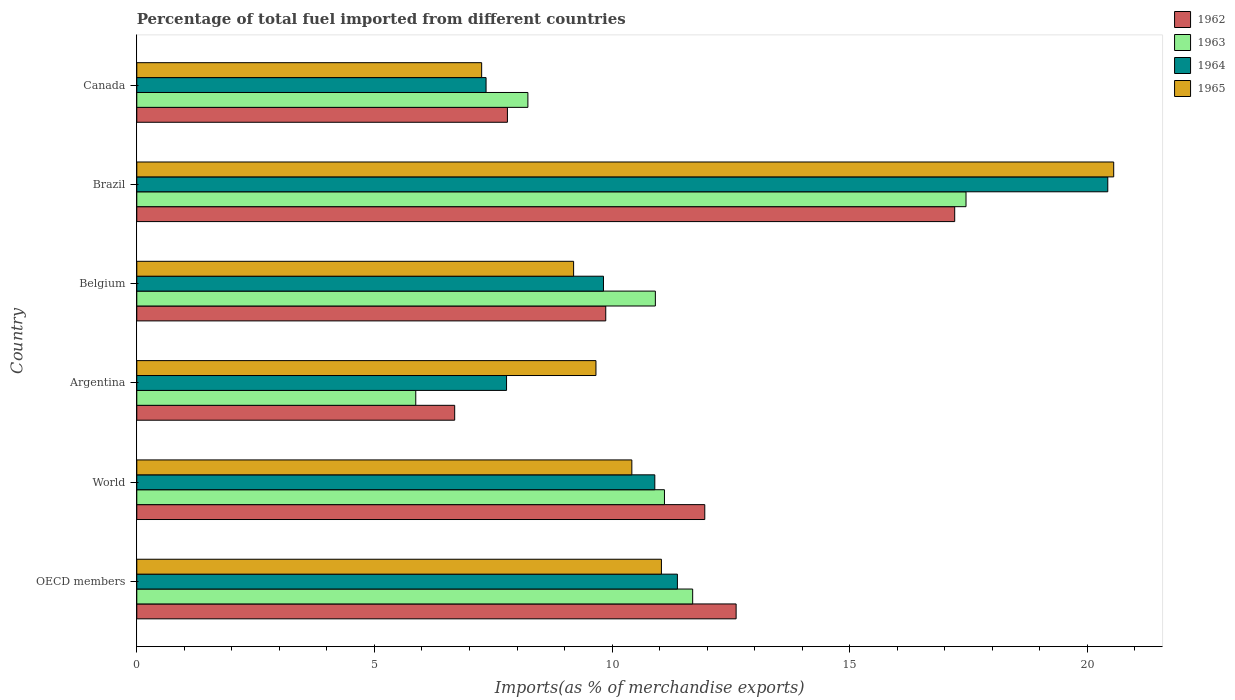How many different coloured bars are there?
Your answer should be very brief. 4. Are the number of bars per tick equal to the number of legend labels?
Provide a succinct answer. Yes. Are the number of bars on each tick of the Y-axis equal?
Provide a short and direct response. Yes. How many bars are there on the 3rd tick from the bottom?
Keep it short and to the point. 4. What is the percentage of imports to different countries in 1965 in Argentina?
Your answer should be compact. 9.66. Across all countries, what is the maximum percentage of imports to different countries in 1962?
Keep it short and to the point. 17.21. Across all countries, what is the minimum percentage of imports to different countries in 1963?
Keep it short and to the point. 5.87. In which country was the percentage of imports to different countries in 1963 minimum?
Give a very brief answer. Argentina. What is the total percentage of imports to different countries in 1965 in the graph?
Provide a succinct answer. 68.12. What is the difference between the percentage of imports to different countries in 1962 in Canada and that in OECD members?
Provide a succinct answer. -4.81. What is the difference between the percentage of imports to different countries in 1964 in OECD members and the percentage of imports to different countries in 1962 in Argentina?
Give a very brief answer. 4.69. What is the average percentage of imports to different countries in 1965 per country?
Provide a succinct answer. 11.35. What is the difference between the percentage of imports to different countries in 1963 and percentage of imports to different countries in 1962 in Belgium?
Provide a short and direct response. 1.04. In how many countries, is the percentage of imports to different countries in 1965 greater than 14 %?
Make the answer very short. 1. What is the ratio of the percentage of imports to different countries in 1963 in Belgium to that in OECD members?
Provide a succinct answer. 0.93. Is the percentage of imports to different countries in 1964 in Canada less than that in OECD members?
Ensure brevity in your answer.  Yes. What is the difference between the highest and the second highest percentage of imports to different countries in 1965?
Provide a short and direct response. 9.52. What is the difference between the highest and the lowest percentage of imports to different countries in 1965?
Keep it short and to the point. 13.3. In how many countries, is the percentage of imports to different countries in 1963 greater than the average percentage of imports to different countries in 1963 taken over all countries?
Provide a short and direct response. 4. What does the 2nd bar from the top in Belgium represents?
Make the answer very short. 1964. What does the 3rd bar from the bottom in Brazil represents?
Provide a succinct answer. 1964. Is it the case that in every country, the sum of the percentage of imports to different countries in 1965 and percentage of imports to different countries in 1962 is greater than the percentage of imports to different countries in 1963?
Your response must be concise. Yes. How many bars are there?
Provide a short and direct response. 24. Are all the bars in the graph horizontal?
Offer a very short reply. Yes. What is the difference between two consecutive major ticks on the X-axis?
Your answer should be compact. 5. Are the values on the major ticks of X-axis written in scientific E-notation?
Give a very brief answer. No. Does the graph contain any zero values?
Offer a terse response. No. How are the legend labels stacked?
Offer a terse response. Vertical. What is the title of the graph?
Make the answer very short. Percentage of total fuel imported from different countries. What is the label or title of the X-axis?
Your answer should be compact. Imports(as % of merchandise exports). What is the label or title of the Y-axis?
Provide a succinct answer. Country. What is the Imports(as % of merchandise exports) of 1962 in OECD members?
Your answer should be very brief. 12.61. What is the Imports(as % of merchandise exports) in 1963 in OECD members?
Your answer should be very brief. 11.7. What is the Imports(as % of merchandise exports) of 1964 in OECD members?
Offer a very short reply. 11.37. What is the Imports(as % of merchandise exports) of 1965 in OECD members?
Offer a very short reply. 11.04. What is the Imports(as % of merchandise exports) in 1962 in World?
Your answer should be very brief. 11.95. What is the Imports(as % of merchandise exports) in 1963 in World?
Make the answer very short. 11.1. What is the Imports(as % of merchandise exports) of 1964 in World?
Your answer should be compact. 10.9. What is the Imports(as % of merchandise exports) in 1965 in World?
Make the answer very short. 10.42. What is the Imports(as % of merchandise exports) of 1962 in Argentina?
Offer a terse response. 6.69. What is the Imports(as % of merchandise exports) in 1963 in Argentina?
Make the answer very short. 5.87. What is the Imports(as % of merchandise exports) of 1964 in Argentina?
Provide a succinct answer. 7.78. What is the Imports(as % of merchandise exports) of 1965 in Argentina?
Provide a short and direct response. 9.66. What is the Imports(as % of merchandise exports) in 1962 in Belgium?
Ensure brevity in your answer.  9.87. What is the Imports(as % of merchandise exports) in 1963 in Belgium?
Give a very brief answer. 10.91. What is the Imports(as % of merchandise exports) in 1964 in Belgium?
Offer a very short reply. 9.82. What is the Imports(as % of merchandise exports) in 1965 in Belgium?
Make the answer very short. 9.19. What is the Imports(as % of merchandise exports) of 1962 in Brazil?
Make the answer very short. 17.21. What is the Imports(as % of merchandise exports) in 1963 in Brazil?
Your answer should be compact. 17.45. What is the Imports(as % of merchandise exports) of 1964 in Brazil?
Ensure brevity in your answer.  20.43. What is the Imports(as % of merchandise exports) in 1965 in Brazil?
Your answer should be very brief. 20.55. What is the Imports(as % of merchandise exports) in 1962 in Canada?
Provide a short and direct response. 7.8. What is the Imports(as % of merchandise exports) of 1963 in Canada?
Your answer should be very brief. 8.23. What is the Imports(as % of merchandise exports) of 1964 in Canada?
Your answer should be compact. 7.35. What is the Imports(as % of merchandise exports) in 1965 in Canada?
Ensure brevity in your answer.  7.26. Across all countries, what is the maximum Imports(as % of merchandise exports) of 1962?
Provide a succinct answer. 17.21. Across all countries, what is the maximum Imports(as % of merchandise exports) of 1963?
Provide a short and direct response. 17.45. Across all countries, what is the maximum Imports(as % of merchandise exports) of 1964?
Your response must be concise. 20.43. Across all countries, what is the maximum Imports(as % of merchandise exports) in 1965?
Keep it short and to the point. 20.55. Across all countries, what is the minimum Imports(as % of merchandise exports) in 1962?
Make the answer very short. 6.69. Across all countries, what is the minimum Imports(as % of merchandise exports) in 1963?
Give a very brief answer. 5.87. Across all countries, what is the minimum Imports(as % of merchandise exports) of 1964?
Offer a very short reply. 7.35. Across all countries, what is the minimum Imports(as % of merchandise exports) in 1965?
Give a very brief answer. 7.26. What is the total Imports(as % of merchandise exports) of 1962 in the graph?
Your response must be concise. 66.12. What is the total Imports(as % of merchandise exports) in 1963 in the graph?
Offer a very short reply. 65.25. What is the total Imports(as % of merchandise exports) of 1964 in the graph?
Provide a succinct answer. 67.65. What is the total Imports(as % of merchandise exports) in 1965 in the graph?
Your answer should be compact. 68.12. What is the difference between the Imports(as % of merchandise exports) in 1962 in OECD members and that in World?
Offer a very short reply. 0.66. What is the difference between the Imports(as % of merchandise exports) in 1963 in OECD members and that in World?
Provide a short and direct response. 0.59. What is the difference between the Imports(as % of merchandise exports) in 1964 in OECD members and that in World?
Give a very brief answer. 0.48. What is the difference between the Imports(as % of merchandise exports) of 1965 in OECD members and that in World?
Offer a very short reply. 0.62. What is the difference between the Imports(as % of merchandise exports) in 1962 in OECD members and that in Argentina?
Offer a terse response. 5.92. What is the difference between the Imports(as % of merchandise exports) in 1963 in OECD members and that in Argentina?
Ensure brevity in your answer.  5.83. What is the difference between the Imports(as % of merchandise exports) of 1964 in OECD members and that in Argentina?
Offer a terse response. 3.59. What is the difference between the Imports(as % of merchandise exports) of 1965 in OECD members and that in Argentina?
Offer a terse response. 1.38. What is the difference between the Imports(as % of merchandise exports) in 1962 in OECD members and that in Belgium?
Your response must be concise. 2.74. What is the difference between the Imports(as % of merchandise exports) in 1963 in OECD members and that in Belgium?
Keep it short and to the point. 0.79. What is the difference between the Imports(as % of merchandise exports) of 1964 in OECD members and that in Belgium?
Keep it short and to the point. 1.56. What is the difference between the Imports(as % of merchandise exports) in 1965 in OECD members and that in Belgium?
Provide a short and direct response. 1.85. What is the difference between the Imports(as % of merchandise exports) of 1962 in OECD members and that in Brazil?
Keep it short and to the point. -4.6. What is the difference between the Imports(as % of merchandise exports) of 1963 in OECD members and that in Brazil?
Provide a succinct answer. -5.75. What is the difference between the Imports(as % of merchandise exports) of 1964 in OECD members and that in Brazil?
Your answer should be very brief. -9.06. What is the difference between the Imports(as % of merchandise exports) in 1965 in OECD members and that in Brazil?
Ensure brevity in your answer.  -9.52. What is the difference between the Imports(as % of merchandise exports) in 1962 in OECD members and that in Canada?
Keep it short and to the point. 4.81. What is the difference between the Imports(as % of merchandise exports) in 1963 in OECD members and that in Canada?
Your answer should be very brief. 3.47. What is the difference between the Imports(as % of merchandise exports) in 1964 in OECD members and that in Canada?
Offer a very short reply. 4.03. What is the difference between the Imports(as % of merchandise exports) of 1965 in OECD members and that in Canada?
Offer a terse response. 3.78. What is the difference between the Imports(as % of merchandise exports) of 1962 in World and that in Argentina?
Provide a succinct answer. 5.26. What is the difference between the Imports(as % of merchandise exports) in 1963 in World and that in Argentina?
Your answer should be compact. 5.23. What is the difference between the Imports(as % of merchandise exports) in 1964 in World and that in Argentina?
Offer a very short reply. 3.12. What is the difference between the Imports(as % of merchandise exports) in 1965 in World and that in Argentina?
Your answer should be compact. 0.76. What is the difference between the Imports(as % of merchandise exports) in 1962 in World and that in Belgium?
Offer a terse response. 2.08. What is the difference between the Imports(as % of merchandise exports) in 1963 in World and that in Belgium?
Keep it short and to the point. 0.19. What is the difference between the Imports(as % of merchandise exports) of 1964 in World and that in Belgium?
Provide a succinct answer. 1.08. What is the difference between the Imports(as % of merchandise exports) in 1965 in World and that in Belgium?
Ensure brevity in your answer.  1.23. What is the difference between the Imports(as % of merchandise exports) in 1962 in World and that in Brazil?
Your answer should be compact. -5.26. What is the difference between the Imports(as % of merchandise exports) of 1963 in World and that in Brazil?
Your answer should be compact. -6.34. What is the difference between the Imports(as % of merchandise exports) in 1964 in World and that in Brazil?
Your answer should be compact. -9.53. What is the difference between the Imports(as % of merchandise exports) of 1965 in World and that in Brazil?
Provide a succinct answer. -10.14. What is the difference between the Imports(as % of merchandise exports) in 1962 in World and that in Canada?
Keep it short and to the point. 4.15. What is the difference between the Imports(as % of merchandise exports) in 1963 in World and that in Canada?
Give a very brief answer. 2.87. What is the difference between the Imports(as % of merchandise exports) of 1964 in World and that in Canada?
Ensure brevity in your answer.  3.55. What is the difference between the Imports(as % of merchandise exports) of 1965 in World and that in Canada?
Your response must be concise. 3.16. What is the difference between the Imports(as % of merchandise exports) in 1962 in Argentina and that in Belgium?
Ensure brevity in your answer.  -3.18. What is the difference between the Imports(as % of merchandise exports) of 1963 in Argentina and that in Belgium?
Offer a terse response. -5.04. What is the difference between the Imports(as % of merchandise exports) in 1964 in Argentina and that in Belgium?
Your response must be concise. -2.04. What is the difference between the Imports(as % of merchandise exports) of 1965 in Argentina and that in Belgium?
Make the answer very short. 0.47. What is the difference between the Imports(as % of merchandise exports) in 1962 in Argentina and that in Brazil?
Offer a terse response. -10.52. What is the difference between the Imports(as % of merchandise exports) of 1963 in Argentina and that in Brazil?
Offer a very short reply. -11.58. What is the difference between the Imports(as % of merchandise exports) of 1964 in Argentina and that in Brazil?
Your answer should be very brief. -12.65. What is the difference between the Imports(as % of merchandise exports) of 1965 in Argentina and that in Brazil?
Offer a very short reply. -10.89. What is the difference between the Imports(as % of merchandise exports) in 1962 in Argentina and that in Canada?
Provide a succinct answer. -1.11. What is the difference between the Imports(as % of merchandise exports) in 1963 in Argentina and that in Canada?
Ensure brevity in your answer.  -2.36. What is the difference between the Imports(as % of merchandise exports) in 1964 in Argentina and that in Canada?
Keep it short and to the point. 0.43. What is the difference between the Imports(as % of merchandise exports) in 1965 in Argentina and that in Canada?
Provide a short and direct response. 2.4. What is the difference between the Imports(as % of merchandise exports) of 1962 in Belgium and that in Brazil?
Your answer should be very brief. -7.34. What is the difference between the Imports(as % of merchandise exports) of 1963 in Belgium and that in Brazil?
Offer a very short reply. -6.54. What is the difference between the Imports(as % of merchandise exports) of 1964 in Belgium and that in Brazil?
Offer a terse response. -10.61. What is the difference between the Imports(as % of merchandise exports) of 1965 in Belgium and that in Brazil?
Ensure brevity in your answer.  -11.36. What is the difference between the Imports(as % of merchandise exports) in 1962 in Belgium and that in Canada?
Give a very brief answer. 2.07. What is the difference between the Imports(as % of merchandise exports) of 1963 in Belgium and that in Canada?
Your answer should be very brief. 2.68. What is the difference between the Imports(as % of merchandise exports) in 1964 in Belgium and that in Canada?
Offer a very short reply. 2.47. What is the difference between the Imports(as % of merchandise exports) of 1965 in Belgium and that in Canada?
Offer a very short reply. 1.93. What is the difference between the Imports(as % of merchandise exports) in 1962 in Brazil and that in Canada?
Provide a succinct answer. 9.41. What is the difference between the Imports(as % of merchandise exports) of 1963 in Brazil and that in Canada?
Provide a short and direct response. 9.22. What is the difference between the Imports(as % of merchandise exports) of 1964 in Brazil and that in Canada?
Offer a very short reply. 13.08. What is the difference between the Imports(as % of merchandise exports) of 1965 in Brazil and that in Canada?
Give a very brief answer. 13.3. What is the difference between the Imports(as % of merchandise exports) in 1962 in OECD members and the Imports(as % of merchandise exports) in 1963 in World?
Give a very brief answer. 1.51. What is the difference between the Imports(as % of merchandise exports) in 1962 in OECD members and the Imports(as % of merchandise exports) in 1964 in World?
Ensure brevity in your answer.  1.71. What is the difference between the Imports(as % of merchandise exports) of 1962 in OECD members and the Imports(as % of merchandise exports) of 1965 in World?
Provide a succinct answer. 2.19. What is the difference between the Imports(as % of merchandise exports) in 1963 in OECD members and the Imports(as % of merchandise exports) in 1964 in World?
Provide a short and direct response. 0.8. What is the difference between the Imports(as % of merchandise exports) in 1963 in OECD members and the Imports(as % of merchandise exports) in 1965 in World?
Offer a terse response. 1.28. What is the difference between the Imports(as % of merchandise exports) in 1964 in OECD members and the Imports(as % of merchandise exports) in 1965 in World?
Ensure brevity in your answer.  0.96. What is the difference between the Imports(as % of merchandise exports) in 1962 in OECD members and the Imports(as % of merchandise exports) in 1963 in Argentina?
Provide a short and direct response. 6.74. What is the difference between the Imports(as % of merchandise exports) in 1962 in OECD members and the Imports(as % of merchandise exports) in 1964 in Argentina?
Offer a terse response. 4.83. What is the difference between the Imports(as % of merchandise exports) in 1962 in OECD members and the Imports(as % of merchandise exports) in 1965 in Argentina?
Provide a succinct answer. 2.95. What is the difference between the Imports(as % of merchandise exports) of 1963 in OECD members and the Imports(as % of merchandise exports) of 1964 in Argentina?
Give a very brief answer. 3.92. What is the difference between the Imports(as % of merchandise exports) in 1963 in OECD members and the Imports(as % of merchandise exports) in 1965 in Argentina?
Provide a short and direct response. 2.04. What is the difference between the Imports(as % of merchandise exports) in 1964 in OECD members and the Imports(as % of merchandise exports) in 1965 in Argentina?
Ensure brevity in your answer.  1.71. What is the difference between the Imports(as % of merchandise exports) in 1962 in OECD members and the Imports(as % of merchandise exports) in 1963 in Belgium?
Make the answer very short. 1.7. What is the difference between the Imports(as % of merchandise exports) in 1962 in OECD members and the Imports(as % of merchandise exports) in 1964 in Belgium?
Make the answer very short. 2.79. What is the difference between the Imports(as % of merchandise exports) of 1962 in OECD members and the Imports(as % of merchandise exports) of 1965 in Belgium?
Offer a terse response. 3.42. What is the difference between the Imports(as % of merchandise exports) in 1963 in OECD members and the Imports(as % of merchandise exports) in 1964 in Belgium?
Offer a very short reply. 1.88. What is the difference between the Imports(as % of merchandise exports) in 1963 in OECD members and the Imports(as % of merchandise exports) in 1965 in Belgium?
Offer a very short reply. 2.51. What is the difference between the Imports(as % of merchandise exports) of 1964 in OECD members and the Imports(as % of merchandise exports) of 1965 in Belgium?
Keep it short and to the point. 2.18. What is the difference between the Imports(as % of merchandise exports) of 1962 in OECD members and the Imports(as % of merchandise exports) of 1963 in Brazil?
Your response must be concise. -4.84. What is the difference between the Imports(as % of merchandise exports) in 1962 in OECD members and the Imports(as % of merchandise exports) in 1964 in Brazil?
Offer a very short reply. -7.82. What is the difference between the Imports(as % of merchandise exports) in 1962 in OECD members and the Imports(as % of merchandise exports) in 1965 in Brazil?
Your answer should be very brief. -7.94. What is the difference between the Imports(as % of merchandise exports) of 1963 in OECD members and the Imports(as % of merchandise exports) of 1964 in Brazil?
Your response must be concise. -8.73. What is the difference between the Imports(as % of merchandise exports) of 1963 in OECD members and the Imports(as % of merchandise exports) of 1965 in Brazil?
Your answer should be very brief. -8.86. What is the difference between the Imports(as % of merchandise exports) of 1964 in OECD members and the Imports(as % of merchandise exports) of 1965 in Brazil?
Keep it short and to the point. -9.18. What is the difference between the Imports(as % of merchandise exports) of 1962 in OECD members and the Imports(as % of merchandise exports) of 1963 in Canada?
Your answer should be very brief. 4.38. What is the difference between the Imports(as % of merchandise exports) in 1962 in OECD members and the Imports(as % of merchandise exports) in 1964 in Canada?
Your response must be concise. 5.26. What is the difference between the Imports(as % of merchandise exports) in 1962 in OECD members and the Imports(as % of merchandise exports) in 1965 in Canada?
Ensure brevity in your answer.  5.35. What is the difference between the Imports(as % of merchandise exports) in 1963 in OECD members and the Imports(as % of merchandise exports) in 1964 in Canada?
Make the answer very short. 4.35. What is the difference between the Imports(as % of merchandise exports) in 1963 in OECD members and the Imports(as % of merchandise exports) in 1965 in Canada?
Keep it short and to the point. 4.44. What is the difference between the Imports(as % of merchandise exports) of 1964 in OECD members and the Imports(as % of merchandise exports) of 1965 in Canada?
Your answer should be compact. 4.12. What is the difference between the Imports(as % of merchandise exports) of 1962 in World and the Imports(as % of merchandise exports) of 1963 in Argentina?
Offer a terse response. 6.08. What is the difference between the Imports(as % of merchandise exports) of 1962 in World and the Imports(as % of merchandise exports) of 1964 in Argentina?
Your answer should be compact. 4.17. What is the difference between the Imports(as % of merchandise exports) in 1962 in World and the Imports(as % of merchandise exports) in 1965 in Argentina?
Your answer should be compact. 2.29. What is the difference between the Imports(as % of merchandise exports) in 1963 in World and the Imports(as % of merchandise exports) in 1964 in Argentina?
Your answer should be compact. 3.32. What is the difference between the Imports(as % of merchandise exports) in 1963 in World and the Imports(as % of merchandise exports) in 1965 in Argentina?
Keep it short and to the point. 1.44. What is the difference between the Imports(as % of merchandise exports) of 1964 in World and the Imports(as % of merchandise exports) of 1965 in Argentina?
Offer a terse response. 1.24. What is the difference between the Imports(as % of merchandise exports) of 1962 in World and the Imports(as % of merchandise exports) of 1963 in Belgium?
Your response must be concise. 1.04. What is the difference between the Imports(as % of merchandise exports) of 1962 in World and the Imports(as % of merchandise exports) of 1964 in Belgium?
Offer a terse response. 2.13. What is the difference between the Imports(as % of merchandise exports) in 1962 in World and the Imports(as % of merchandise exports) in 1965 in Belgium?
Your response must be concise. 2.76. What is the difference between the Imports(as % of merchandise exports) of 1963 in World and the Imports(as % of merchandise exports) of 1964 in Belgium?
Give a very brief answer. 1.28. What is the difference between the Imports(as % of merchandise exports) in 1963 in World and the Imports(as % of merchandise exports) in 1965 in Belgium?
Give a very brief answer. 1.91. What is the difference between the Imports(as % of merchandise exports) in 1964 in World and the Imports(as % of merchandise exports) in 1965 in Belgium?
Give a very brief answer. 1.71. What is the difference between the Imports(as % of merchandise exports) in 1962 in World and the Imports(as % of merchandise exports) in 1963 in Brazil?
Your answer should be compact. -5.5. What is the difference between the Imports(as % of merchandise exports) in 1962 in World and the Imports(as % of merchandise exports) in 1964 in Brazil?
Offer a very short reply. -8.48. What is the difference between the Imports(as % of merchandise exports) of 1962 in World and the Imports(as % of merchandise exports) of 1965 in Brazil?
Keep it short and to the point. -8.6. What is the difference between the Imports(as % of merchandise exports) of 1963 in World and the Imports(as % of merchandise exports) of 1964 in Brazil?
Your response must be concise. -9.33. What is the difference between the Imports(as % of merchandise exports) in 1963 in World and the Imports(as % of merchandise exports) in 1965 in Brazil?
Offer a very short reply. -9.45. What is the difference between the Imports(as % of merchandise exports) of 1964 in World and the Imports(as % of merchandise exports) of 1965 in Brazil?
Ensure brevity in your answer.  -9.66. What is the difference between the Imports(as % of merchandise exports) of 1962 in World and the Imports(as % of merchandise exports) of 1963 in Canada?
Provide a short and direct response. 3.72. What is the difference between the Imports(as % of merchandise exports) of 1962 in World and the Imports(as % of merchandise exports) of 1964 in Canada?
Offer a terse response. 4.6. What is the difference between the Imports(as % of merchandise exports) in 1962 in World and the Imports(as % of merchandise exports) in 1965 in Canada?
Give a very brief answer. 4.69. What is the difference between the Imports(as % of merchandise exports) in 1963 in World and the Imports(as % of merchandise exports) in 1964 in Canada?
Keep it short and to the point. 3.75. What is the difference between the Imports(as % of merchandise exports) in 1963 in World and the Imports(as % of merchandise exports) in 1965 in Canada?
Your answer should be compact. 3.85. What is the difference between the Imports(as % of merchandise exports) in 1964 in World and the Imports(as % of merchandise exports) in 1965 in Canada?
Your response must be concise. 3.64. What is the difference between the Imports(as % of merchandise exports) of 1962 in Argentina and the Imports(as % of merchandise exports) of 1963 in Belgium?
Your response must be concise. -4.22. What is the difference between the Imports(as % of merchandise exports) of 1962 in Argentina and the Imports(as % of merchandise exports) of 1964 in Belgium?
Make the answer very short. -3.13. What is the difference between the Imports(as % of merchandise exports) of 1962 in Argentina and the Imports(as % of merchandise exports) of 1965 in Belgium?
Your response must be concise. -2.5. What is the difference between the Imports(as % of merchandise exports) of 1963 in Argentina and the Imports(as % of merchandise exports) of 1964 in Belgium?
Ensure brevity in your answer.  -3.95. What is the difference between the Imports(as % of merchandise exports) in 1963 in Argentina and the Imports(as % of merchandise exports) in 1965 in Belgium?
Your answer should be compact. -3.32. What is the difference between the Imports(as % of merchandise exports) of 1964 in Argentina and the Imports(as % of merchandise exports) of 1965 in Belgium?
Make the answer very short. -1.41. What is the difference between the Imports(as % of merchandise exports) in 1962 in Argentina and the Imports(as % of merchandise exports) in 1963 in Brazil?
Your answer should be very brief. -10.76. What is the difference between the Imports(as % of merchandise exports) in 1962 in Argentina and the Imports(as % of merchandise exports) in 1964 in Brazil?
Provide a succinct answer. -13.74. What is the difference between the Imports(as % of merchandise exports) of 1962 in Argentina and the Imports(as % of merchandise exports) of 1965 in Brazil?
Offer a terse response. -13.87. What is the difference between the Imports(as % of merchandise exports) in 1963 in Argentina and the Imports(as % of merchandise exports) in 1964 in Brazil?
Your answer should be compact. -14.56. What is the difference between the Imports(as % of merchandise exports) in 1963 in Argentina and the Imports(as % of merchandise exports) in 1965 in Brazil?
Your answer should be compact. -14.68. What is the difference between the Imports(as % of merchandise exports) of 1964 in Argentina and the Imports(as % of merchandise exports) of 1965 in Brazil?
Offer a terse response. -12.77. What is the difference between the Imports(as % of merchandise exports) of 1962 in Argentina and the Imports(as % of merchandise exports) of 1963 in Canada?
Your answer should be compact. -1.54. What is the difference between the Imports(as % of merchandise exports) in 1962 in Argentina and the Imports(as % of merchandise exports) in 1964 in Canada?
Keep it short and to the point. -0.66. What is the difference between the Imports(as % of merchandise exports) of 1962 in Argentina and the Imports(as % of merchandise exports) of 1965 in Canada?
Keep it short and to the point. -0.57. What is the difference between the Imports(as % of merchandise exports) in 1963 in Argentina and the Imports(as % of merchandise exports) in 1964 in Canada?
Offer a terse response. -1.48. What is the difference between the Imports(as % of merchandise exports) of 1963 in Argentina and the Imports(as % of merchandise exports) of 1965 in Canada?
Provide a short and direct response. -1.39. What is the difference between the Imports(as % of merchandise exports) of 1964 in Argentina and the Imports(as % of merchandise exports) of 1965 in Canada?
Provide a succinct answer. 0.52. What is the difference between the Imports(as % of merchandise exports) in 1962 in Belgium and the Imports(as % of merchandise exports) in 1963 in Brazil?
Your answer should be very brief. -7.58. What is the difference between the Imports(as % of merchandise exports) in 1962 in Belgium and the Imports(as % of merchandise exports) in 1964 in Brazil?
Your answer should be very brief. -10.56. What is the difference between the Imports(as % of merchandise exports) of 1962 in Belgium and the Imports(as % of merchandise exports) of 1965 in Brazil?
Provide a short and direct response. -10.69. What is the difference between the Imports(as % of merchandise exports) of 1963 in Belgium and the Imports(as % of merchandise exports) of 1964 in Brazil?
Provide a short and direct response. -9.52. What is the difference between the Imports(as % of merchandise exports) of 1963 in Belgium and the Imports(as % of merchandise exports) of 1965 in Brazil?
Give a very brief answer. -9.64. What is the difference between the Imports(as % of merchandise exports) in 1964 in Belgium and the Imports(as % of merchandise exports) in 1965 in Brazil?
Ensure brevity in your answer.  -10.74. What is the difference between the Imports(as % of merchandise exports) in 1962 in Belgium and the Imports(as % of merchandise exports) in 1963 in Canada?
Offer a terse response. 1.64. What is the difference between the Imports(as % of merchandise exports) of 1962 in Belgium and the Imports(as % of merchandise exports) of 1964 in Canada?
Offer a terse response. 2.52. What is the difference between the Imports(as % of merchandise exports) of 1962 in Belgium and the Imports(as % of merchandise exports) of 1965 in Canada?
Provide a succinct answer. 2.61. What is the difference between the Imports(as % of merchandise exports) in 1963 in Belgium and the Imports(as % of merchandise exports) in 1964 in Canada?
Your answer should be compact. 3.56. What is the difference between the Imports(as % of merchandise exports) in 1963 in Belgium and the Imports(as % of merchandise exports) in 1965 in Canada?
Offer a very short reply. 3.65. What is the difference between the Imports(as % of merchandise exports) in 1964 in Belgium and the Imports(as % of merchandise exports) in 1965 in Canada?
Provide a succinct answer. 2.56. What is the difference between the Imports(as % of merchandise exports) in 1962 in Brazil and the Imports(as % of merchandise exports) in 1963 in Canada?
Make the answer very short. 8.98. What is the difference between the Imports(as % of merchandise exports) of 1962 in Brazil and the Imports(as % of merchandise exports) of 1964 in Canada?
Ensure brevity in your answer.  9.86. What is the difference between the Imports(as % of merchandise exports) of 1962 in Brazil and the Imports(as % of merchandise exports) of 1965 in Canada?
Your response must be concise. 9.95. What is the difference between the Imports(as % of merchandise exports) of 1963 in Brazil and the Imports(as % of merchandise exports) of 1964 in Canada?
Offer a very short reply. 10.1. What is the difference between the Imports(as % of merchandise exports) in 1963 in Brazil and the Imports(as % of merchandise exports) in 1965 in Canada?
Provide a succinct answer. 10.19. What is the difference between the Imports(as % of merchandise exports) in 1964 in Brazil and the Imports(as % of merchandise exports) in 1965 in Canada?
Offer a terse response. 13.17. What is the average Imports(as % of merchandise exports) of 1962 per country?
Give a very brief answer. 11.02. What is the average Imports(as % of merchandise exports) in 1963 per country?
Offer a terse response. 10.88. What is the average Imports(as % of merchandise exports) in 1964 per country?
Your answer should be very brief. 11.28. What is the average Imports(as % of merchandise exports) in 1965 per country?
Give a very brief answer. 11.35. What is the difference between the Imports(as % of merchandise exports) of 1962 and Imports(as % of merchandise exports) of 1963 in OECD members?
Give a very brief answer. 0.91. What is the difference between the Imports(as % of merchandise exports) of 1962 and Imports(as % of merchandise exports) of 1964 in OECD members?
Offer a terse response. 1.24. What is the difference between the Imports(as % of merchandise exports) of 1962 and Imports(as % of merchandise exports) of 1965 in OECD members?
Give a very brief answer. 1.57. What is the difference between the Imports(as % of merchandise exports) in 1963 and Imports(as % of merchandise exports) in 1964 in OECD members?
Your response must be concise. 0.32. What is the difference between the Imports(as % of merchandise exports) in 1963 and Imports(as % of merchandise exports) in 1965 in OECD members?
Keep it short and to the point. 0.66. What is the difference between the Imports(as % of merchandise exports) of 1964 and Imports(as % of merchandise exports) of 1965 in OECD members?
Make the answer very short. 0.34. What is the difference between the Imports(as % of merchandise exports) of 1962 and Imports(as % of merchandise exports) of 1963 in World?
Make the answer very short. 0.85. What is the difference between the Imports(as % of merchandise exports) of 1962 and Imports(as % of merchandise exports) of 1964 in World?
Provide a short and direct response. 1.05. What is the difference between the Imports(as % of merchandise exports) in 1962 and Imports(as % of merchandise exports) in 1965 in World?
Your answer should be very brief. 1.53. What is the difference between the Imports(as % of merchandise exports) in 1963 and Imports(as % of merchandise exports) in 1964 in World?
Your response must be concise. 0.2. What is the difference between the Imports(as % of merchandise exports) of 1963 and Imports(as % of merchandise exports) of 1965 in World?
Ensure brevity in your answer.  0.69. What is the difference between the Imports(as % of merchandise exports) of 1964 and Imports(as % of merchandise exports) of 1965 in World?
Give a very brief answer. 0.48. What is the difference between the Imports(as % of merchandise exports) in 1962 and Imports(as % of merchandise exports) in 1963 in Argentina?
Give a very brief answer. 0.82. What is the difference between the Imports(as % of merchandise exports) of 1962 and Imports(as % of merchandise exports) of 1964 in Argentina?
Provide a short and direct response. -1.09. What is the difference between the Imports(as % of merchandise exports) of 1962 and Imports(as % of merchandise exports) of 1965 in Argentina?
Offer a very short reply. -2.97. What is the difference between the Imports(as % of merchandise exports) of 1963 and Imports(as % of merchandise exports) of 1964 in Argentina?
Offer a terse response. -1.91. What is the difference between the Imports(as % of merchandise exports) in 1963 and Imports(as % of merchandise exports) in 1965 in Argentina?
Make the answer very short. -3.79. What is the difference between the Imports(as % of merchandise exports) in 1964 and Imports(as % of merchandise exports) in 1965 in Argentina?
Your answer should be compact. -1.88. What is the difference between the Imports(as % of merchandise exports) of 1962 and Imports(as % of merchandise exports) of 1963 in Belgium?
Offer a terse response. -1.04. What is the difference between the Imports(as % of merchandise exports) in 1962 and Imports(as % of merchandise exports) in 1964 in Belgium?
Offer a terse response. 0.05. What is the difference between the Imports(as % of merchandise exports) of 1962 and Imports(as % of merchandise exports) of 1965 in Belgium?
Your response must be concise. 0.68. What is the difference between the Imports(as % of merchandise exports) of 1963 and Imports(as % of merchandise exports) of 1964 in Belgium?
Provide a short and direct response. 1.09. What is the difference between the Imports(as % of merchandise exports) of 1963 and Imports(as % of merchandise exports) of 1965 in Belgium?
Provide a succinct answer. 1.72. What is the difference between the Imports(as % of merchandise exports) in 1964 and Imports(as % of merchandise exports) in 1965 in Belgium?
Your answer should be very brief. 0.63. What is the difference between the Imports(as % of merchandise exports) of 1962 and Imports(as % of merchandise exports) of 1963 in Brazil?
Offer a very short reply. -0.24. What is the difference between the Imports(as % of merchandise exports) of 1962 and Imports(as % of merchandise exports) of 1964 in Brazil?
Offer a terse response. -3.22. What is the difference between the Imports(as % of merchandise exports) of 1962 and Imports(as % of merchandise exports) of 1965 in Brazil?
Your response must be concise. -3.35. What is the difference between the Imports(as % of merchandise exports) of 1963 and Imports(as % of merchandise exports) of 1964 in Brazil?
Keep it short and to the point. -2.98. What is the difference between the Imports(as % of merchandise exports) in 1963 and Imports(as % of merchandise exports) in 1965 in Brazil?
Your answer should be very brief. -3.11. What is the difference between the Imports(as % of merchandise exports) of 1964 and Imports(as % of merchandise exports) of 1965 in Brazil?
Provide a short and direct response. -0.12. What is the difference between the Imports(as % of merchandise exports) in 1962 and Imports(as % of merchandise exports) in 1963 in Canada?
Provide a succinct answer. -0.43. What is the difference between the Imports(as % of merchandise exports) of 1962 and Imports(as % of merchandise exports) of 1964 in Canada?
Keep it short and to the point. 0.45. What is the difference between the Imports(as % of merchandise exports) in 1962 and Imports(as % of merchandise exports) in 1965 in Canada?
Offer a very short reply. 0.54. What is the difference between the Imports(as % of merchandise exports) in 1963 and Imports(as % of merchandise exports) in 1964 in Canada?
Give a very brief answer. 0.88. What is the difference between the Imports(as % of merchandise exports) of 1963 and Imports(as % of merchandise exports) of 1965 in Canada?
Ensure brevity in your answer.  0.97. What is the difference between the Imports(as % of merchandise exports) in 1964 and Imports(as % of merchandise exports) in 1965 in Canada?
Ensure brevity in your answer.  0.09. What is the ratio of the Imports(as % of merchandise exports) of 1962 in OECD members to that in World?
Provide a short and direct response. 1.06. What is the ratio of the Imports(as % of merchandise exports) in 1963 in OECD members to that in World?
Ensure brevity in your answer.  1.05. What is the ratio of the Imports(as % of merchandise exports) of 1964 in OECD members to that in World?
Keep it short and to the point. 1.04. What is the ratio of the Imports(as % of merchandise exports) in 1965 in OECD members to that in World?
Provide a succinct answer. 1.06. What is the ratio of the Imports(as % of merchandise exports) in 1962 in OECD members to that in Argentina?
Provide a succinct answer. 1.89. What is the ratio of the Imports(as % of merchandise exports) of 1963 in OECD members to that in Argentina?
Make the answer very short. 1.99. What is the ratio of the Imports(as % of merchandise exports) in 1964 in OECD members to that in Argentina?
Your response must be concise. 1.46. What is the ratio of the Imports(as % of merchandise exports) in 1965 in OECD members to that in Argentina?
Offer a very short reply. 1.14. What is the ratio of the Imports(as % of merchandise exports) in 1962 in OECD members to that in Belgium?
Your response must be concise. 1.28. What is the ratio of the Imports(as % of merchandise exports) in 1963 in OECD members to that in Belgium?
Offer a very short reply. 1.07. What is the ratio of the Imports(as % of merchandise exports) in 1964 in OECD members to that in Belgium?
Keep it short and to the point. 1.16. What is the ratio of the Imports(as % of merchandise exports) of 1965 in OECD members to that in Belgium?
Offer a terse response. 1.2. What is the ratio of the Imports(as % of merchandise exports) in 1962 in OECD members to that in Brazil?
Your answer should be compact. 0.73. What is the ratio of the Imports(as % of merchandise exports) of 1963 in OECD members to that in Brazil?
Give a very brief answer. 0.67. What is the ratio of the Imports(as % of merchandise exports) of 1964 in OECD members to that in Brazil?
Offer a terse response. 0.56. What is the ratio of the Imports(as % of merchandise exports) in 1965 in OECD members to that in Brazil?
Ensure brevity in your answer.  0.54. What is the ratio of the Imports(as % of merchandise exports) of 1962 in OECD members to that in Canada?
Your response must be concise. 1.62. What is the ratio of the Imports(as % of merchandise exports) of 1963 in OECD members to that in Canada?
Your response must be concise. 1.42. What is the ratio of the Imports(as % of merchandise exports) of 1964 in OECD members to that in Canada?
Keep it short and to the point. 1.55. What is the ratio of the Imports(as % of merchandise exports) in 1965 in OECD members to that in Canada?
Keep it short and to the point. 1.52. What is the ratio of the Imports(as % of merchandise exports) of 1962 in World to that in Argentina?
Your answer should be very brief. 1.79. What is the ratio of the Imports(as % of merchandise exports) of 1963 in World to that in Argentina?
Keep it short and to the point. 1.89. What is the ratio of the Imports(as % of merchandise exports) of 1964 in World to that in Argentina?
Your answer should be very brief. 1.4. What is the ratio of the Imports(as % of merchandise exports) in 1965 in World to that in Argentina?
Your response must be concise. 1.08. What is the ratio of the Imports(as % of merchandise exports) of 1962 in World to that in Belgium?
Your response must be concise. 1.21. What is the ratio of the Imports(as % of merchandise exports) in 1963 in World to that in Belgium?
Make the answer very short. 1.02. What is the ratio of the Imports(as % of merchandise exports) in 1964 in World to that in Belgium?
Ensure brevity in your answer.  1.11. What is the ratio of the Imports(as % of merchandise exports) of 1965 in World to that in Belgium?
Give a very brief answer. 1.13. What is the ratio of the Imports(as % of merchandise exports) in 1962 in World to that in Brazil?
Make the answer very short. 0.69. What is the ratio of the Imports(as % of merchandise exports) of 1963 in World to that in Brazil?
Provide a succinct answer. 0.64. What is the ratio of the Imports(as % of merchandise exports) in 1964 in World to that in Brazil?
Your response must be concise. 0.53. What is the ratio of the Imports(as % of merchandise exports) in 1965 in World to that in Brazil?
Make the answer very short. 0.51. What is the ratio of the Imports(as % of merchandise exports) of 1962 in World to that in Canada?
Provide a short and direct response. 1.53. What is the ratio of the Imports(as % of merchandise exports) in 1963 in World to that in Canada?
Provide a succinct answer. 1.35. What is the ratio of the Imports(as % of merchandise exports) of 1964 in World to that in Canada?
Offer a very short reply. 1.48. What is the ratio of the Imports(as % of merchandise exports) in 1965 in World to that in Canada?
Your response must be concise. 1.44. What is the ratio of the Imports(as % of merchandise exports) in 1962 in Argentina to that in Belgium?
Provide a succinct answer. 0.68. What is the ratio of the Imports(as % of merchandise exports) in 1963 in Argentina to that in Belgium?
Ensure brevity in your answer.  0.54. What is the ratio of the Imports(as % of merchandise exports) in 1964 in Argentina to that in Belgium?
Your answer should be compact. 0.79. What is the ratio of the Imports(as % of merchandise exports) in 1965 in Argentina to that in Belgium?
Your answer should be compact. 1.05. What is the ratio of the Imports(as % of merchandise exports) in 1962 in Argentina to that in Brazil?
Offer a very short reply. 0.39. What is the ratio of the Imports(as % of merchandise exports) of 1963 in Argentina to that in Brazil?
Ensure brevity in your answer.  0.34. What is the ratio of the Imports(as % of merchandise exports) of 1964 in Argentina to that in Brazil?
Your answer should be compact. 0.38. What is the ratio of the Imports(as % of merchandise exports) in 1965 in Argentina to that in Brazil?
Provide a short and direct response. 0.47. What is the ratio of the Imports(as % of merchandise exports) in 1962 in Argentina to that in Canada?
Provide a succinct answer. 0.86. What is the ratio of the Imports(as % of merchandise exports) of 1963 in Argentina to that in Canada?
Your answer should be compact. 0.71. What is the ratio of the Imports(as % of merchandise exports) of 1964 in Argentina to that in Canada?
Your answer should be compact. 1.06. What is the ratio of the Imports(as % of merchandise exports) of 1965 in Argentina to that in Canada?
Your answer should be compact. 1.33. What is the ratio of the Imports(as % of merchandise exports) of 1962 in Belgium to that in Brazil?
Ensure brevity in your answer.  0.57. What is the ratio of the Imports(as % of merchandise exports) of 1963 in Belgium to that in Brazil?
Ensure brevity in your answer.  0.63. What is the ratio of the Imports(as % of merchandise exports) in 1964 in Belgium to that in Brazil?
Your answer should be compact. 0.48. What is the ratio of the Imports(as % of merchandise exports) of 1965 in Belgium to that in Brazil?
Your answer should be very brief. 0.45. What is the ratio of the Imports(as % of merchandise exports) in 1962 in Belgium to that in Canada?
Provide a short and direct response. 1.27. What is the ratio of the Imports(as % of merchandise exports) in 1963 in Belgium to that in Canada?
Your answer should be very brief. 1.33. What is the ratio of the Imports(as % of merchandise exports) of 1964 in Belgium to that in Canada?
Give a very brief answer. 1.34. What is the ratio of the Imports(as % of merchandise exports) in 1965 in Belgium to that in Canada?
Provide a short and direct response. 1.27. What is the ratio of the Imports(as % of merchandise exports) in 1962 in Brazil to that in Canada?
Give a very brief answer. 2.21. What is the ratio of the Imports(as % of merchandise exports) of 1963 in Brazil to that in Canada?
Give a very brief answer. 2.12. What is the ratio of the Imports(as % of merchandise exports) of 1964 in Brazil to that in Canada?
Provide a succinct answer. 2.78. What is the ratio of the Imports(as % of merchandise exports) of 1965 in Brazil to that in Canada?
Keep it short and to the point. 2.83. What is the difference between the highest and the second highest Imports(as % of merchandise exports) in 1962?
Provide a succinct answer. 4.6. What is the difference between the highest and the second highest Imports(as % of merchandise exports) in 1963?
Provide a short and direct response. 5.75. What is the difference between the highest and the second highest Imports(as % of merchandise exports) of 1964?
Your response must be concise. 9.06. What is the difference between the highest and the second highest Imports(as % of merchandise exports) of 1965?
Give a very brief answer. 9.52. What is the difference between the highest and the lowest Imports(as % of merchandise exports) of 1962?
Offer a very short reply. 10.52. What is the difference between the highest and the lowest Imports(as % of merchandise exports) of 1963?
Keep it short and to the point. 11.58. What is the difference between the highest and the lowest Imports(as % of merchandise exports) of 1964?
Offer a terse response. 13.08. What is the difference between the highest and the lowest Imports(as % of merchandise exports) of 1965?
Offer a terse response. 13.3. 